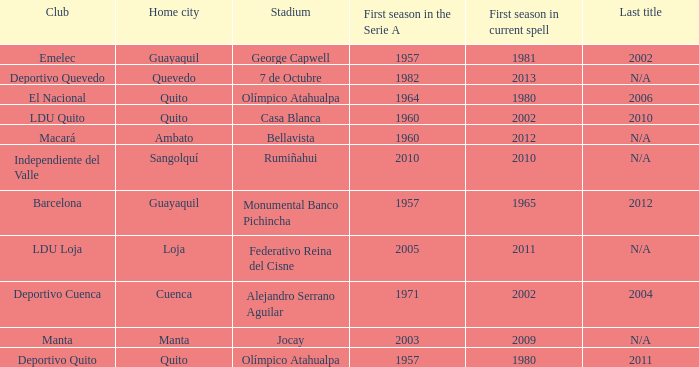Name the last title for cuenca 2004.0. 